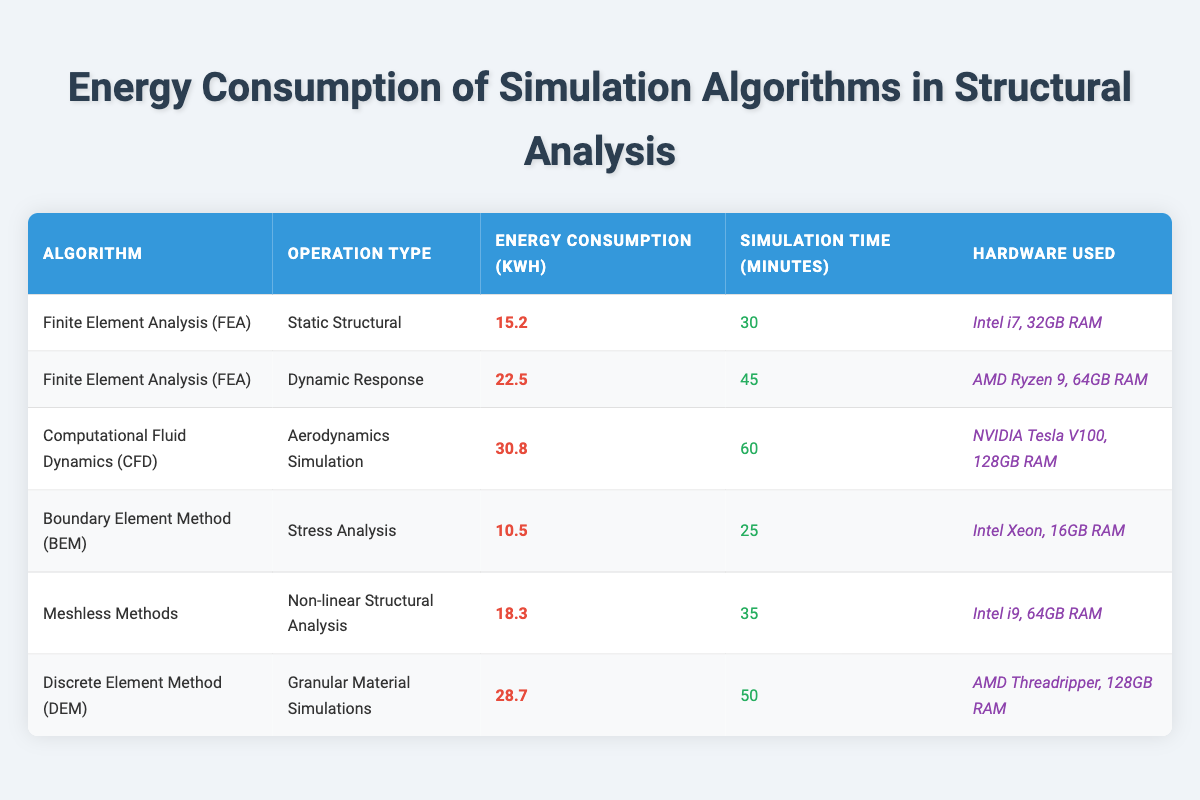What is the energy consumption of the Discrete Element Method? The Discrete Element Method is listed in the table with an energy consumption value of 28.7 kWh.
Answer: 28.7 kWh Which algorithm takes the longest to simulate? The algorithm that takes the longest simulation time is Computational Fluid Dynamics (CFD) with a simulation time of 60 minutes.
Answer: 60 minutes What is the average energy consumption of the Finite Element Analysis (FEA) algorithms? For FEA, there are two types: Static Structural (15.2 kWh) and Dynamic Response (22.5 kWh). The average is calculated as (15.2 + 22.5) / 2 = 18.85 kWh.
Answer: 18.85 kWh Is the energy consumption of the Boundary Element Method higher than 15 kWh? The Boundary Element Method has an energy consumption of 10.5 kWh, which is lower than 15 kWh.
Answer: No What is the difference in energy consumption between the Finite Element Analysis for Dynamic Response and the Discrete Element Method? The energy consumption of the Finite Element Analysis for Dynamic Response is 22.5 kWh, while the Discrete Element Method is 28.7 kWh. The difference is calculated as 28.7 - 22.5 = 6.2 kWh.
Answer: 6.2 kWh Which hardware is used for the most energy-consuming algorithm? The algorithm with the highest energy consumption is Computational Fluid Dynamics (CFD), which uses the NVIDIA Tesla V100 with 128GB RAM.
Answer: NVIDIA Tesla V100, 128GB RAM How many algorithms require more than 20 kWh of energy? The algorithms that require more than 20 kWh are the Dynamic Response (22.5 kWh), Aerodynamics Simulation (30.8 kWh), and Discrete Element Method (28.7 kWh), totaling three algorithms.
Answer: 3 Which algorithm has the lowest energy consumption, and what is its value? The algorithm with the lowest energy consumption is Boundary Element Method at 10.5 kWh.
Answer: 10.5 kWh 